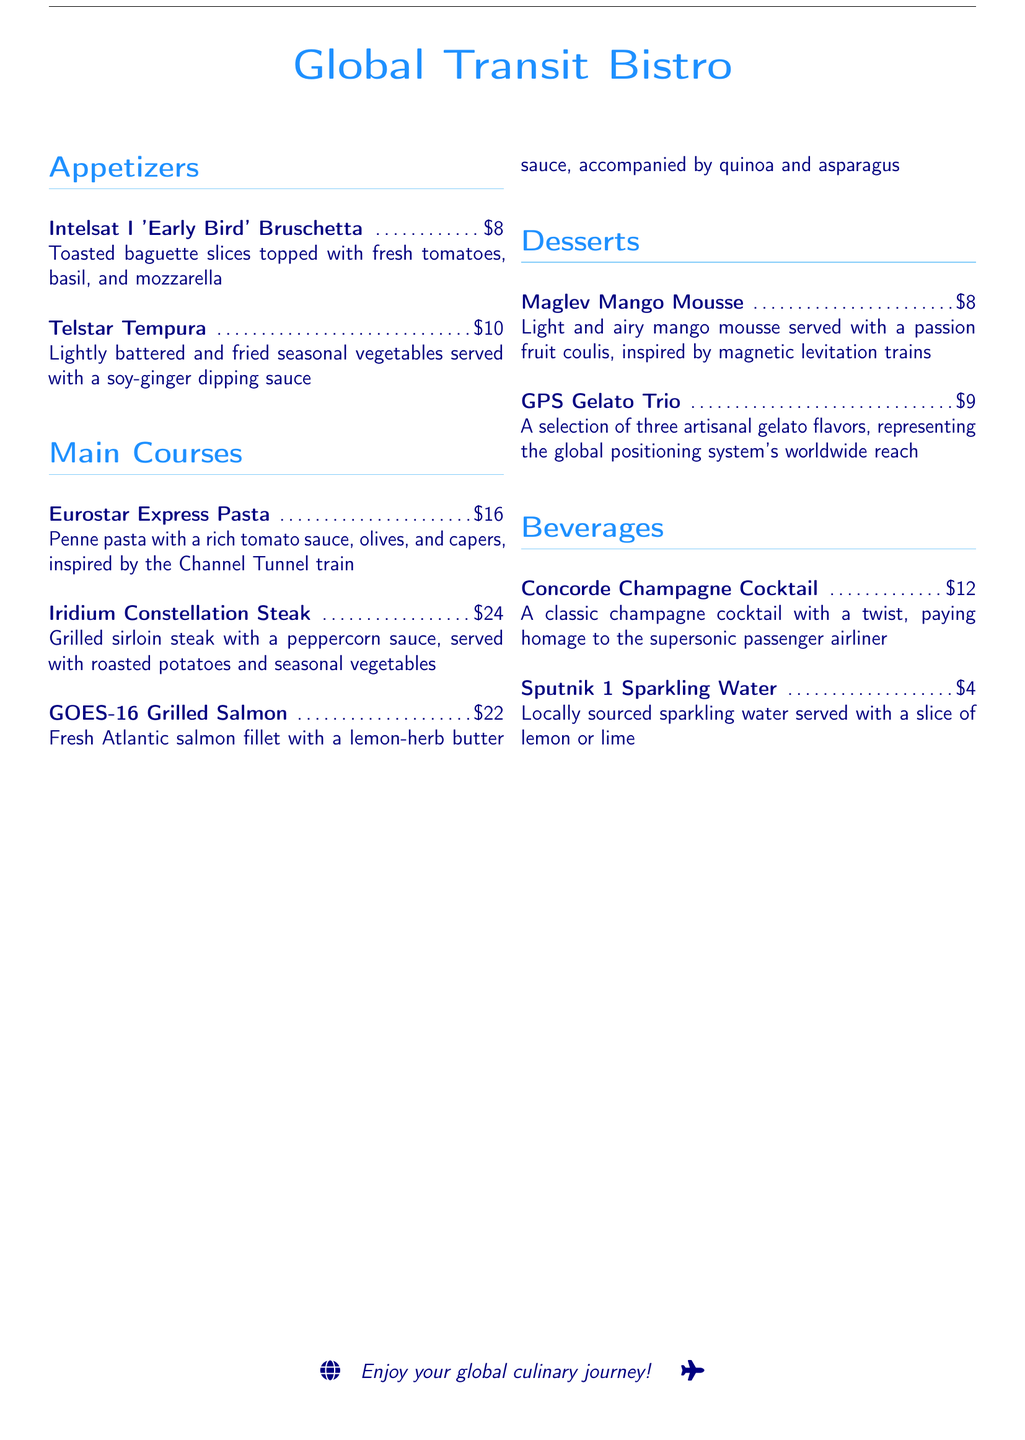What is the name of the appetizer? The name of the first appetizer listed is "Intelsat I 'Early Bird' Bruschetta."
Answer: Intelsat I 'Early Bird' Bruschetta How much does the GOES-16 Grilled Salmon cost? The menu lists the price of the GOES-16 Grilled Salmon, which is $22.
Answer: $22 Which dessert is inspired by magnetic levitation trains? The dessert inspired by magnetic levitation trains is "Maglev Mango Mousse."
Answer: Maglev Mango Mousse What is paired with the Concorde Champagne Cocktail? The menu states that the Concorde Champagne Cocktail is a "classic champagne cocktail with a twist."
Answer: twist How many artisanal gelato flavors are included in the GPS Gelato Trio? The GPS Gelato Trio includes a selection of three flavors, as mentioned in the description.
Answer: three What type of vegetables are in the Telstar Tempura dish? The Telstar Tempura dish consists of "lightly battered and fried seasonal vegetables."
Answer: seasonal vegetables Which main course dish has a peppercorn sauce? The main course dish with a peppercorn sauce is "Iridium Constellation Steak."
Answer: Iridium Constellation Steak How much is the Sputnik 1 Sparkling Water? The price of the Sputnik 1 Sparkling Water is clearly stated as $4.
Answer: $4 What type of pasta is used in the Eurostar Express Pasta? The dish Eurostar Express Pasta is made with "penne pasta."
Answer: penne pasta 